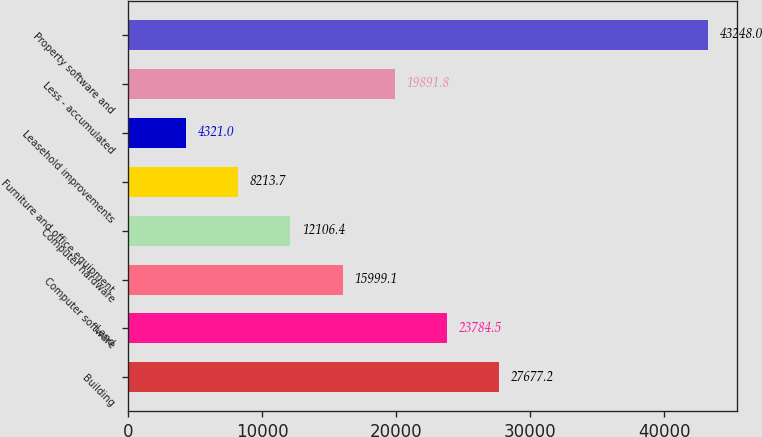Convert chart to OTSL. <chart><loc_0><loc_0><loc_500><loc_500><bar_chart><fcel>Building<fcel>Land<fcel>Computer software<fcel>Computer hardware<fcel>Furniture and office equipment<fcel>Leasehold improvements<fcel>Less - accumulated<fcel>Property software and<nl><fcel>27677.2<fcel>23784.5<fcel>15999.1<fcel>12106.4<fcel>8213.7<fcel>4321<fcel>19891.8<fcel>43248<nl></chart> 